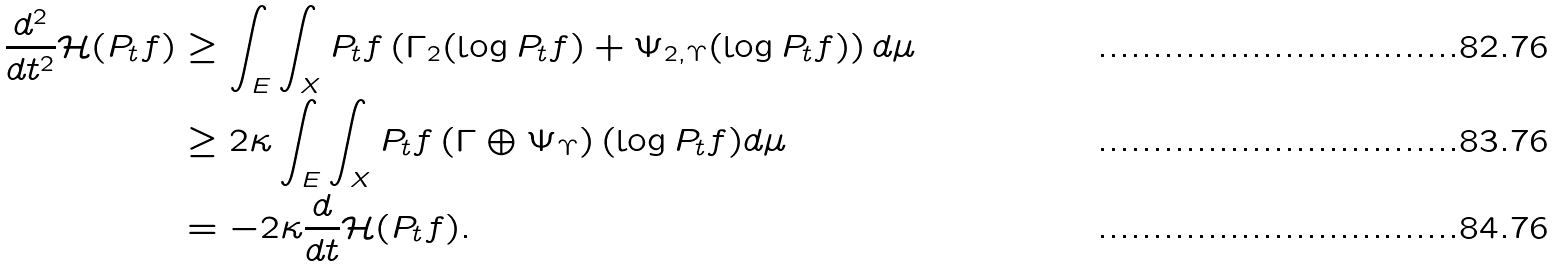Convert formula to latex. <formula><loc_0><loc_0><loc_500><loc_500>\frac { d ^ { 2 } } { d t ^ { 2 } } \mathcal { H } ( P _ { t } f ) & \geq \int _ { E } \int _ { X } P _ { t } f \left ( \Gamma _ { 2 } ( \log P _ { t } f ) + \Psi _ { 2 , \Upsilon } ( \log P _ { t } f ) \right ) d \mu \\ & \geq 2 \kappa \int _ { E } \int _ { X } P _ { t } f \left ( \Gamma \oplus \Psi _ { \Upsilon } \right ) ( \log P _ { t } f ) d \mu \\ & = - 2 \kappa \frac { d } { d t } \mathcal { H } ( P _ { t } f ) .</formula> 